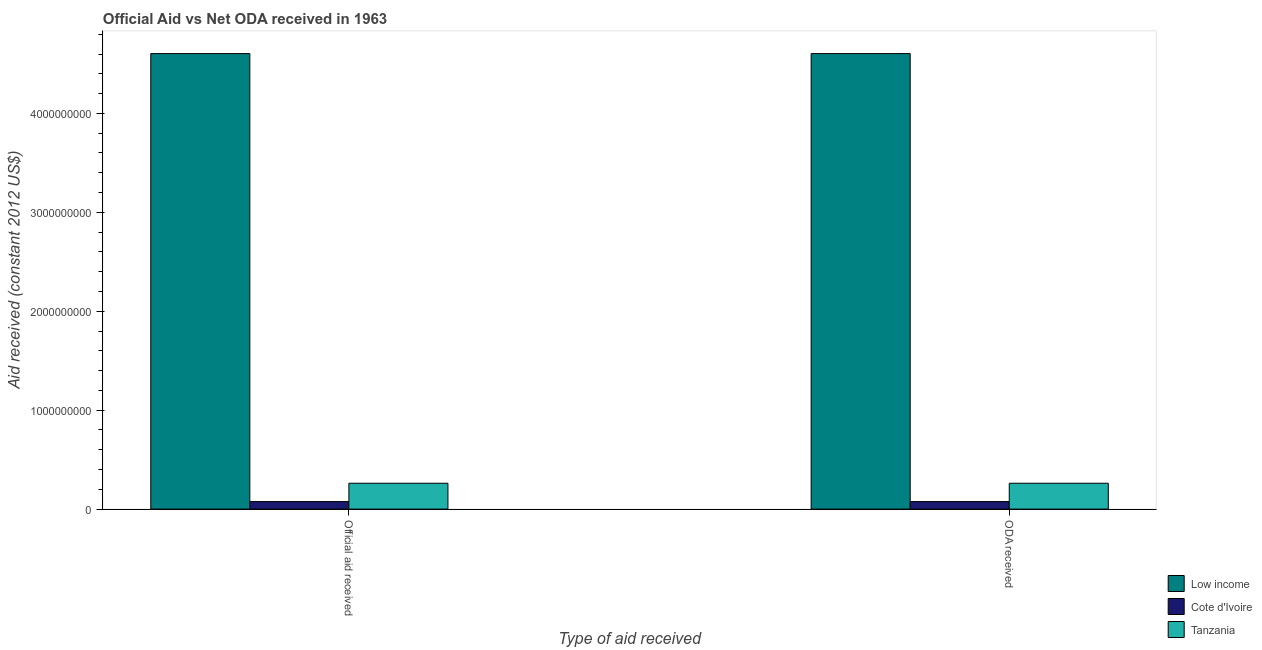Are the number of bars per tick equal to the number of legend labels?
Provide a short and direct response. Yes. How many bars are there on the 2nd tick from the left?
Offer a terse response. 3. How many bars are there on the 1st tick from the right?
Offer a terse response. 3. What is the label of the 2nd group of bars from the left?
Offer a terse response. ODA received. What is the oda received in Tanzania?
Your response must be concise. 2.61e+08. Across all countries, what is the maximum official aid received?
Make the answer very short. 4.60e+09. Across all countries, what is the minimum official aid received?
Provide a succinct answer. 7.61e+07. In which country was the oda received maximum?
Offer a terse response. Low income. In which country was the oda received minimum?
Offer a very short reply. Cote d'Ivoire. What is the total official aid received in the graph?
Make the answer very short. 4.94e+09. What is the difference between the oda received in Low income and that in Cote d'Ivoire?
Your answer should be compact. 4.53e+09. What is the difference between the official aid received in Tanzania and the oda received in Low income?
Your response must be concise. -4.34e+09. What is the average oda received per country?
Ensure brevity in your answer.  1.65e+09. In how many countries, is the oda received greater than 1600000000 US$?
Provide a succinct answer. 1. What is the ratio of the oda received in Low income to that in Tanzania?
Your answer should be compact. 17.61. Is the oda received in Cote d'Ivoire less than that in Tanzania?
Give a very brief answer. Yes. What does the 2nd bar from the left in Official aid received represents?
Ensure brevity in your answer.  Cote d'Ivoire. What does the 1st bar from the right in Official aid received represents?
Ensure brevity in your answer.  Tanzania. How many bars are there?
Offer a very short reply. 6. How many countries are there in the graph?
Keep it short and to the point. 3. What is the difference between two consecutive major ticks on the Y-axis?
Provide a short and direct response. 1.00e+09. Are the values on the major ticks of Y-axis written in scientific E-notation?
Make the answer very short. No. How are the legend labels stacked?
Make the answer very short. Vertical. What is the title of the graph?
Offer a very short reply. Official Aid vs Net ODA received in 1963 . Does "Middle East & North Africa (all income levels)" appear as one of the legend labels in the graph?
Provide a succinct answer. No. What is the label or title of the X-axis?
Your answer should be compact. Type of aid received. What is the label or title of the Y-axis?
Keep it short and to the point. Aid received (constant 2012 US$). What is the Aid received (constant 2012 US$) in Low income in Official aid received?
Ensure brevity in your answer.  4.60e+09. What is the Aid received (constant 2012 US$) of Cote d'Ivoire in Official aid received?
Make the answer very short. 7.61e+07. What is the Aid received (constant 2012 US$) of Tanzania in Official aid received?
Give a very brief answer. 2.61e+08. What is the Aid received (constant 2012 US$) in Low income in ODA received?
Provide a succinct answer. 4.60e+09. What is the Aid received (constant 2012 US$) in Cote d'Ivoire in ODA received?
Keep it short and to the point. 7.61e+07. What is the Aid received (constant 2012 US$) in Tanzania in ODA received?
Keep it short and to the point. 2.61e+08. Across all Type of aid received, what is the maximum Aid received (constant 2012 US$) of Low income?
Ensure brevity in your answer.  4.60e+09. Across all Type of aid received, what is the maximum Aid received (constant 2012 US$) in Cote d'Ivoire?
Your answer should be very brief. 7.61e+07. Across all Type of aid received, what is the maximum Aid received (constant 2012 US$) in Tanzania?
Provide a short and direct response. 2.61e+08. Across all Type of aid received, what is the minimum Aid received (constant 2012 US$) in Low income?
Your answer should be very brief. 4.60e+09. Across all Type of aid received, what is the minimum Aid received (constant 2012 US$) of Cote d'Ivoire?
Your response must be concise. 7.61e+07. Across all Type of aid received, what is the minimum Aid received (constant 2012 US$) in Tanzania?
Offer a very short reply. 2.61e+08. What is the total Aid received (constant 2012 US$) of Low income in the graph?
Give a very brief answer. 9.21e+09. What is the total Aid received (constant 2012 US$) in Cote d'Ivoire in the graph?
Provide a succinct answer. 1.52e+08. What is the total Aid received (constant 2012 US$) in Tanzania in the graph?
Your answer should be compact. 5.23e+08. What is the difference between the Aid received (constant 2012 US$) in Low income in Official aid received and that in ODA received?
Your response must be concise. 0. What is the difference between the Aid received (constant 2012 US$) of Low income in Official aid received and the Aid received (constant 2012 US$) of Cote d'Ivoire in ODA received?
Offer a very short reply. 4.53e+09. What is the difference between the Aid received (constant 2012 US$) in Low income in Official aid received and the Aid received (constant 2012 US$) in Tanzania in ODA received?
Offer a very short reply. 4.34e+09. What is the difference between the Aid received (constant 2012 US$) of Cote d'Ivoire in Official aid received and the Aid received (constant 2012 US$) of Tanzania in ODA received?
Give a very brief answer. -1.85e+08. What is the average Aid received (constant 2012 US$) in Low income per Type of aid received?
Your answer should be very brief. 4.60e+09. What is the average Aid received (constant 2012 US$) of Cote d'Ivoire per Type of aid received?
Offer a very short reply. 7.61e+07. What is the average Aid received (constant 2012 US$) in Tanzania per Type of aid received?
Your answer should be very brief. 2.61e+08. What is the difference between the Aid received (constant 2012 US$) of Low income and Aid received (constant 2012 US$) of Cote d'Ivoire in Official aid received?
Make the answer very short. 4.53e+09. What is the difference between the Aid received (constant 2012 US$) of Low income and Aid received (constant 2012 US$) of Tanzania in Official aid received?
Your response must be concise. 4.34e+09. What is the difference between the Aid received (constant 2012 US$) in Cote d'Ivoire and Aid received (constant 2012 US$) in Tanzania in Official aid received?
Offer a very short reply. -1.85e+08. What is the difference between the Aid received (constant 2012 US$) in Low income and Aid received (constant 2012 US$) in Cote d'Ivoire in ODA received?
Ensure brevity in your answer.  4.53e+09. What is the difference between the Aid received (constant 2012 US$) in Low income and Aid received (constant 2012 US$) in Tanzania in ODA received?
Offer a terse response. 4.34e+09. What is the difference between the Aid received (constant 2012 US$) in Cote d'Ivoire and Aid received (constant 2012 US$) in Tanzania in ODA received?
Offer a very short reply. -1.85e+08. What is the ratio of the Aid received (constant 2012 US$) of Tanzania in Official aid received to that in ODA received?
Offer a terse response. 1. What is the difference between the highest and the second highest Aid received (constant 2012 US$) of Cote d'Ivoire?
Your answer should be compact. 0. What is the difference between the highest and the lowest Aid received (constant 2012 US$) in Cote d'Ivoire?
Provide a short and direct response. 0. What is the difference between the highest and the lowest Aid received (constant 2012 US$) in Tanzania?
Your answer should be compact. 0. 